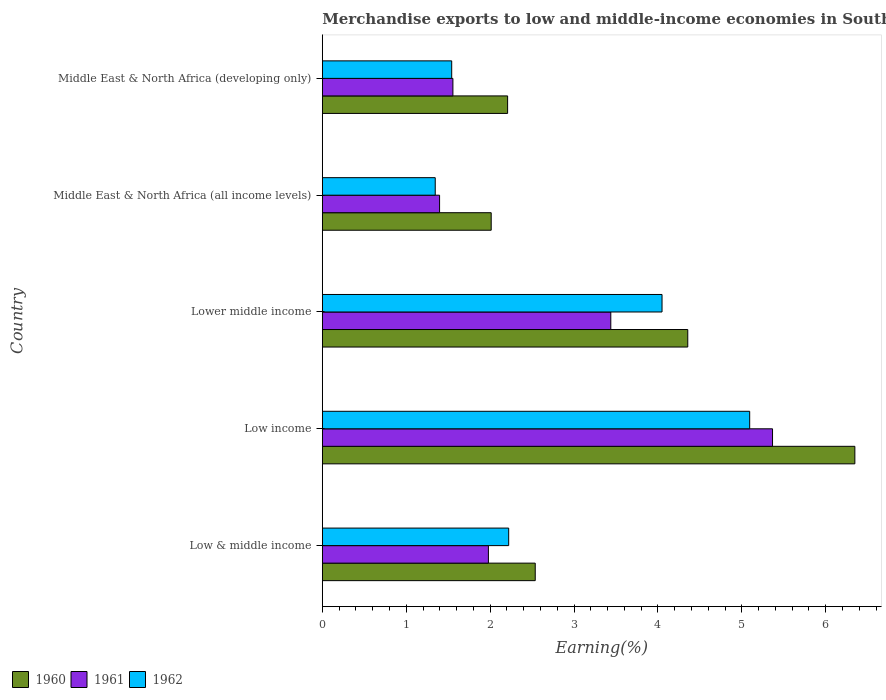How many different coloured bars are there?
Offer a very short reply. 3. How many bars are there on the 2nd tick from the top?
Give a very brief answer. 3. How many bars are there on the 5th tick from the bottom?
Your response must be concise. 3. What is the label of the 2nd group of bars from the top?
Provide a succinct answer. Middle East & North Africa (all income levels). What is the percentage of amount earned from merchandise exports in 1961 in Lower middle income?
Your answer should be compact. 3.44. Across all countries, what is the maximum percentage of amount earned from merchandise exports in 1960?
Offer a very short reply. 6.35. Across all countries, what is the minimum percentage of amount earned from merchandise exports in 1962?
Your answer should be compact. 1.35. In which country was the percentage of amount earned from merchandise exports in 1961 maximum?
Make the answer very short. Low income. In which country was the percentage of amount earned from merchandise exports in 1961 minimum?
Keep it short and to the point. Middle East & North Africa (all income levels). What is the total percentage of amount earned from merchandise exports in 1962 in the graph?
Offer a terse response. 14.25. What is the difference between the percentage of amount earned from merchandise exports in 1960 in Low & middle income and that in Low income?
Offer a very short reply. -3.81. What is the difference between the percentage of amount earned from merchandise exports in 1960 in Lower middle income and the percentage of amount earned from merchandise exports in 1961 in Middle East & North Africa (all income levels)?
Make the answer very short. 2.96. What is the average percentage of amount earned from merchandise exports in 1962 per country?
Make the answer very short. 2.85. What is the difference between the percentage of amount earned from merchandise exports in 1960 and percentage of amount earned from merchandise exports in 1961 in Low income?
Your answer should be compact. 0.98. What is the ratio of the percentage of amount earned from merchandise exports in 1962 in Lower middle income to that in Middle East & North Africa (developing only)?
Make the answer very short. 2.63. Is the percentage of amount earned from merchandise exports in 1962 in Lower middle income less than that in Middle East & North Africa (developing only)?
Ensure brevity in your answer.  No. What is the difference between the highest and the second highest percentage of amount earned from merchandise exports in 1962?
Your answer should be compact. 1.04. What is the difference between the highest and the lowest percentage of amount earned from merchandise exports in 1960?
Your response must be concise. 4.33. In how many countries, is the percentage of amount earned from merchandise exports in 1960 greater than the average percentage of amount earned from merchandise exports in 1960 taken over all countries?
Give a very brief answer. 2. Is it the case that in every country, the sum of the percentage of amount earned from merchandise exports in 1962 and percentage of amount earned from merchandise exports in 1960 is greater than the percentage of amount earned from merchandise exports in 1961?
Keep it short and to the point. Yes. Are all the bars in the graph horizontal?
Give a very brief answer. Yes. How many countries are there in the graph?
Offer a terse response. 5. Are the values on the major ticks of X-axis written in scientific E-notation?
Offer a terse response. No. Where does the legend appear in the graph?
Give a very brief answer. Bottom left. How many legend labels are there?
Your answer should be compact. 3. How are the legend labels stacked?
Give a very brief answer. Horizontal. What is the title of the graph?
Offer a terse response. Merchandise exports to low and middle-income economies in South Asia. What is the label or title of the X-axis?
Offer a very short reply. Earning(%). What is the Earning(%) of 1960 in Low & middle income?
Keep it short and to the point. 2.54. What is the Earning(%) of 1961 in Low & middle income?
Provide a succinct answer. 1.98. What is the Earning(%) in 1962 in Low & middle income?
Provide a short and direct response. 2.22. What is the Earning(%) of 1960 in Low income?
Offer a very short reply. 6.35. What is the Earning(%) in 1961 in Low income?
Keep it short and to the point. 5.37. What is the Earning(%) in 1962 in Low income?
Keep it short and to the point. 5.09. What is the Earning(%) in 1960 in Lower middle income?
Your answer should be very brief. 4.36. What is the Earning(%) of 1961 in Lower middle income?
Provide a short and direct response. 3.44. What is the Earning(%) in 1962 in Lower middle income?
Ensure brevity in your answer.  4.05. What is the Earning(%) in 1960 in Middle East & North Africa (all income levels)?
Keep it short and to the point. 2.01. What is the Earning(%) of 1961 in Middle East & North Africa (all income levels)?
Keep it short and to the point. 1.4. What is the Earning(%) in 1962 in Middle East & North Africa (all income levels)?
Give a very brief answer. 1.35. What is the Earning(%) in 1960 in Middle East & North Africa (developing only)?
Make the answer very short. 2.21. What is the Earning(%) of 1961 in Middle East & North Africa (developing only)?
Your response must be concise. 1.56. What is the Earning(%) of 1962 in Middle East & North Africa (developing only)?
Keep it short and to the point. 1.54. Across all countries, what is the maximum Earning(%) of 1960?
Give a very brief answer. 6.35. Across all countries, what is the maximum Earning(%) in 1961?
Offer a terse response. 5.37. Across all countries, what is the maximum Earning(%) in 1962?
Offer a terse response. 5.09. Across all countries, what is the minimum Earning(%) of 1960?
Offer a very short reply. 2.01. Across all countries, what is the minimum Earning(%) of 1961?
Keep it short and to the point. 1.4. Across all countries, what is the minimum Earning(%) of 1962?
Your response must be concise. 1.35. What is the total Earning(%) in 1960 in the graph?
Make the answer very short. 17.46. What is the total Earning(%) of 1961 in the graph?
Your answer should be very brief. 13.74. What is the total Earning(%) of 1962 in the graph?
Your response must be concise. 14.25. What is the difference between the Earning(%) in 1960 in Low & middle income and that in Low income?
Your response must be concise. -3.81. What is the difference between the Earning(%) in 1961 in Low & middle income and that in Low income?
Keep it short and to the point. -3.39. What is the difference between the Earning(%) in 1962 in Low & middle income and that in Low income?
Make the answer very short. -2.87. What is the difference between the Earning(%) in 1960 in Low & middle income and that in Lower middle income?
Ensure brevity in your answer.  -1.82. What is the difference between the Earning(%) in 1961 in Low & middle income and that in Lower middle income?
Offer a terse response. -1.46. What is the difference between the Earning(%) of 1962 in Low & middle income and that in Lower middle income?
Provide a succinct answer. -1.83. What is the difference between the Earning(%) of 1960 in Low & middle income and that in Middle East & North Africa (all income levels)?
Provide a short and direct response. 0.52. What is the difference between the Earning(%) of 1961 in Low & middle income and that in Middle East & North Africa (all income levels)?
Keep it short and to the point. 0.58. What is the difference between the Earning(%) in 1962 in Low & middle income and that in Middle East & North Africa (all income levels)?
Keep it short and to the point. 0.88. What is the difference between the Earning(%) of 1960 in Low & middle income and that in Middle East & North Africa (developing only)?
Provide a succinct answer. 0.33. What is the difference between the Earning(%) of 1961 in Low & middle income and that in Middle East & North Africa (developing only)?
Offer a terse response. 0.42. What is the difference between the Earning(%) of 1962 in Low & middle income and that in Middle East & North Africa (developing only)?
Your answer should be very brief. 0.68. What is the difference between the Earning(%) in 1960 in Low income and that in Lower middle income?
Offer a terse response. 1.99. What is the difference between the Earning(%) in 1961 in Low income and that in Lower middle income?
Offer a very short reply. 1.93. What is the difference between the Earning(%) of 1962 in Low income and that in Lower middle income?
Your response must be concise. 1.04. What is the difference between the Earning(%) of 1960 in Low income and that in Middle East & North Africa (all income levels)?
Provide a short and direct response. 4.33. What is the difference between the Earning(%) of 1961 in Low income and that in Middle East & North Africa (all income levels)?
Your answer should be very brief. 3.97. What is the difference between the Earning(%) of 1962 in Low income and that in Middle East & North Africa (all income levels)?
Provide a short and direct response. 3.75. What is the difference between the Earning(%) of 1960 in Low income and that in Middle East & North Africa (developing only)?
Provide a succinct answer. 4.14. What is the difference between the Earning(%) of 1961 in Low income and that in Middle East & North Africa (developing only)?
Provide a succinct answer. 3.81. What is the difference between the Earning(%) in 1962 in Low income and that in Middle East & North Africa (developing only)?
Give a very brief answer. 3.55. What is the difference between the Earning(%) of 1960 in Lower middle income and that in Middle East & North Africa (all income levels)?
Your answer should be very brief. 2.34. What is the difference between the Earning(%) of 1961 in Lower middle income and that in Middle East & North Africa (all income levels)?
Your answer should be very brief. 2.04. What is the difference between the Earning(%) in 1962 in Lower middle income and that in Middle East & North Africa (all income levels)?
Provide a short and direct response. 2.7. What is the difference between the Earning(%) in 1960 in Lower middle income and that in Middle East & North Africa (developing only)?
Provide a succinct answer. 2.15. What is the difference between the Earning(%) in 1961 in Lower middle income and that in Middle East & North Africa (developing only)?
Offer a terse response. 1.88. What is the difference between the Earning(%) in 1962 in Lower middle income and that in Middle East & North Africa (developing only)?
Make the answer very short. 2.51. What is the difference between the Earning(%) of 1960 in Middle East & North Africa (all income levels) and that in Middle East & North Africa (developing only)?
Provide a succinct answer. -0.2. What is the difference between the Earning(%) in 1961 in Middle East & North Africa (all income levels) and that in Middle East & North Africa (developing only)?
Offer a very short reply. -0.16. What is the difference between the Earning(%) in 1962 in Middle East & North Africa (all income levels) and that in Middle East & North Africa (developing only)?
Ensure brevity in your answer.  -0.2. What is the difference between the Earning(%) in 1960 in Low & middle income and the Earning(%) in 1961 in Low income?
Keep it short and to the point. -2.83. What is the difference between the Earning(%) in 1960 in Low & middle income and the Earning(%) in 1962 in Low income?
Give a very brief answer. -2.56. What is the difference between the Earning(%) in 1961 in Low & middle income and the Earning(%) in 1962 in Low income?
Give a very brief answer. -3.11. What is the difference between the Earning(%) in 1960 in Low & middle income and the Earning(%) in 1961 in Lower middle income?
Provide a succinct answer. -0.9. What is the difference between the Earning(%) of 1960 in Low & middle income and the Earning(%) of 1962 in Lower middle income?
Give a very brief answer. -1.51. What is the difference between the Earning(%) in 1961 in Low & middle income and the Earning(%) in 1962 in Lower middle income?
Provide a succinct answer. -2.07. What is the difference between the Earning(%) of 1960 in Low & middle income and the Earning(%) of 1961 in Middle East & North Africa (all income levels)?
Make the answer very short. 1.14. What is the difference between the Earning(%) of 1960 in Low & middle income and the Earning(%) of 1962 in Middle East & North Africa (all income levels)?
Give a very brief answer. 1.19. What is the difference between the Earning(%) in 1961 in Low & middle income and the Earning(%) in 1962 in Middle East & North Africa (all income levels)?
Offer a terse response. 0.63. What is the difference between the Earning(%) of 1960 in Low & middle income and the Earning(%) of 1961 in Middle East & North Africa (developing only)?
Ensure brevity in your answer.  0.98. What is the difference between the Earning(%) of 1960 in Low & middle income and the Earning(%) of 1962 in Middle East & North Africa (developing only)?
Keep it short and to the point. 1. What is the difference between the Earning(%) in 1961 in Low & middle income and the Earning(%) in 1962 in Middle East & North Africa (developing only)?
Your answer should be compact. 0.44. What is the difference between the Earning(%) in 1960 in Low income and the Earning(%) in 1961 in Lower middle income?
Ensure brevity in your answer.  2.91. What is the difference between the Earning(%) of 1960 in Low income and the Earning(%) of 1962 in Lower middle income?
Offer a very short reply. 2.3. What is the difference between the Earning(%) in 1961 in Low income and the Earning(%) in 1962 in Lower middle income?
Your response must be concise. 1.32. What is the difference between the Earning(%) in 1960 in Low income and the Earning(%) in 1961 in Middle East & North Africa (all income levels)?
Your answer should be very brief. 4.95. What is the difference between the Earning(%) in 1960 in Low income and the Earning(%) in 1962 in Middle East & North Africa (all income levels)?
Your answer should be compact. 5. What is the difference between the Earning(%) of 1961 in Low income and the Earning(%) of 1962 in Middle East & North Africa (all income levels)?
Offer a terse response. 4.02. What is the difference between the Earning(%) in 1960 in Low income and the Earning(%) in 1961 in Middle East & North Africa (developing only)?
Offer a very short reply. 4.79. What is the difference between the Earning(%) of 1960 in Low income and the Earning(%) of 1962 in Middle East & North Africa (developing only)?
Your response must be concise. 4.81. What is the difference between the Earning(%) of 1961 in Low income and the Earning(%) of 1962 in Middle East & North Africa (developing only)?
Your response must be concise. 3.82. What is the difference between the Earning(%) in 1960 in Lower middle income and the Earning(%) in 1961 in Middle East & North Africa (all income levels)?
Offer a very short reply. 2.96. What is the difference between the Earning(%) of 1960 in Lower middle income and the Earning(%) of 1962 in Middle East & North Africa (all income levels)?
Provide a short and direct response. 3.01. What is the difference between the Earning(%) of 1961 in Lower middle income and the Earning(%) of 1962 in Middle East & North Africa (all income levels)?
Offer a terse response. 2.09. What is the difference between the Earning(%) in 1960 in Lower middle income and the Earning(%) in 1961 in Middle East & North Africa (developing only)?
Provide a short and direct response. 2.8. What is the difference between the Earning(%) in 1960 in Lower middle income and the Earning(%) in 1962 in Middle East & North Africa (developing only)?
Keep it short and to the point. 2.81. What is the difference between the Earning(%) of 1961 in Lower middle income and the Earning(%) of 1962 in Middle East & North Africa (developing only)?
Give a very brief answer. 1.9. What is the difference between the Earning(%) of 1960 in Middle East & North Africa (all income levels) and the Earning(%) of 1961 in Middle East & North Africa (developing only)?
Ensure brevity in your answer.  0.46. What is the difference between the Earning(%) of 1960 in Middle East & North Africa (all income levels) and the Earning(%) of 1962 in Middle East & North Africa (developing only)?
Keep it short and to the point. 0.47. What is the difference between the Earning(%) of 1961 in Middle East & North Africa (all income levels) and the Earning(%) of 1962 in Middle East & North Africa (developing only)?
Your answer should be very brief. -0.14. What is the average Earning(%) in 1960 per country?
Give a very brief answer. 3.49. What is the average Earning(%) of 1961 per country?
Your response must be concise. 2.75. What is the average Earning(%) of 1962 per country?
Provide a succinct answer. 2.85. What is the difference between the Earning(%) in 1960 and Earning(%) in 1961 in Low & middle income?
Provide a short and direct response. 0.56. What is the difference between the Earning(%) in 1960 and Earning(%) in 1962 in Low & middle income?
Offer a terse response. 0.32. What is the difference between the Earning(%) of 1961 and Earning(%) of 1962 in Low & middle income?
Your response must be concise. -0.24. What is the difference between the Earning(%) of 1960 and Earning(%) of 1961 in Low income?
Offer a terse response. 0.98. What is the difference between the Earning(%) of 1960 and Earning(%) of 1962 in Low income?
Keep it short and to the point. 1.25. What is the difference between the Earning(%) in 1961 and Earning(%) in 1962 in Low income?
Your response must be concise. 0.27. What is the difference between the Earning(%) of 1960 and Earning(%) of 1961 in Lower middle income?
Offer a very short reply. 0.92. What is the difference between the Earning(%) of 1960 and Earning(%) of 1962 in Lower middle income?
Offer a very short reply. 0.31. What is the difference between the Earning(%) of 1961 and Earning(%) of 1962 in Lower middle income?
Provide a succinct answer. -0.61. What is the difference between the Earning(%) in 1960 and Earning(%) in 1961 in Middle East & North Africa (all income levels)?
Keep it short and to the point. 0.62. What is the difference between the Earning(%) in 1960 and Earning(%) in 1962 in Middle East & North Africa (all income levels)?
Your response must be concise. 0.67. What is the difference between the Earning(%) of 1961 and Earning(%) of 1962 in Middle East & North Africa (all income levels)?
Offer a very short reply. 0.05. What is the difference between the Earning(%) in 1960 and Earning(%) in 1961 in Middle East & North Africa (developing only)?
Ensure brevity in your answer.  0.65. What is the difference between the Earning(%) in 1960 and Earning(%) in 1962 in Middle East & North Africa (developing only)?
Provide a short and direct response. 0.67. What is the difference between the Earning(%) in 1961 and Earning(%) in 1962 in Middle East & North Africa (developing only)?
Offer a terse response. 0.01. What is the ratio of the Earning(%) of 1960 in Low & middle income to that in Low income?
Offer a terse response. 0.4. What is the ratio of the Earning(%) in 1961 in Low & middle income to that in Low income?
Give a very brief answer. 0.37. What is the ratio of the Earning(%) of 1962 in Low & middle income to that in Low income?
Your answer should be very brief. 0.44. What is the ratio of the Earning(%) of 1960 in Low & middle income to that in Lower middle income?
Ensure brevity in your answer.  0.58. What is the ratio of the Earning(%) in 1961 in Low & middle income to that in Lower middle income?
Ensure brevity in your answer.  0.58. What is the ratio of the Earning(%) in 1962 in Low & middle income to that in Lower middle income?
Offer a terse response. 0.55. What is the ratio of the Earning(%) of 1960 in Low & middle income to that in Middle East & North Africa (all income levels)?
Make the answer very short. 1.26. What is the ratio of the Earning(%) in 1961 in Low & middle income to that in Middle East & North Africa (all income levels)?
Provide a succinct answer. 1.42. What is the ratio of the Earning(%) in 1962 in Low & middle income to that in Middle East & North Africa (all income levels)?
Ensure brevity in your answer.  1.65. What is the ratio of the Earning(%) in 1960 in Low & middle income to that in Middle East & North Africa (developing only)?
Make the answer very short. 1.15. What is the ratio of the Earning(%) in 1961 in Low & middle income to that in Middle East & North Africa (developing only)?
Offer a terse response. 1.27. What is the ratio of the Earning(%) of 1962 in Low & middle income to that in Middle East & North Africa (developing only)?
Make the answer very short. 1.44. What is the ratio of the Earning(%) in 1960 in Low income to that in Lower middle income?
Your answer should be very brief. 1.46. What is the ratio of the Earning(%) in 1961 in Low income to that in Lower middle income?
Offer a very short reply. 1.56. What is the ratio of the Earning(%) of 1962 in Low income to that in Lower middle income?
Offer a very short reply. 1.26. What is the ratio of the Earning(%) of 1960 in Low income to that in Middle East & North Africa (all income levels)?
Your answer should be very brief. 3.15. What is the ratio of the Earning(%) of 1961 in Low income to that in Middle East & North Africa (all income levels)?
Your answer should be very brief. 3.84. What is the ratio of the Earning(%) of 1962 in Low income to that in Middle East & North Africa (all income levels)?
Offer a very short reply. 3.78. What is the ratio of the Earning(%) in 1960 in Low income to that in Middle East & North Africa (developing only)?
Your response must be concise. 2.87. What is the ratio of the Earning(%) in 1961 in Low income to that in Middle East & North Africa (developing only)?
Your response must be concise. 3.45. What is the ratio of the Earning(%) of 1962 in Low income to that in Middle East & North Africa (developing only)?
Ensure brevity in your answer.  3.3. What is the ratio of the Earning(%) in 1960 in Lower middle income to that in Middle East & North Africa (all income levels)?
Keep it short and to the point. 2.16. What is the ratio of the Earning(%) in 1961 in Lower middle income to that in Middle East & North Africa (all income levels)?
Keep it short and to the point. 2.46. What is the ratio of the Earning(%) in 1962 in Lower middle income to that in Middle East & North Africa (all income levels)?
Offer a very short reply. 3.01. What is the ratio of the Earning(%) in 1960 in Lower middle income to that in Middle East & North Africa (developing only)?
Your answer should be compact. 1.97. What is the ratio of the Earning(%) of 1961 in Lower middle income to that in Middle East & North Africa (developing only)?
Your answer should be very brief. 2.21. What is the ratio of the Earning(%) of 1962 in Lower middle income to that in Middle East & North Africa (developing only)?
Give a very brief answer. 2.63. What is the ratio of the Earning(%) in 1960 in Middle East & North Africa (all income levels) to that in Middle East & North Africa (developing only)?
Give a very brief answer. 0.91. What is the ratio of the Earning(%) of 1961 in Middle East & North Africa (all income levels) to that in Middle East & North Africa (developing only)?
Your answer should be very brief. 0.9. What is the ratio of the Earning(%) of 1962 in Middle East & North Africa (all income levels) to that in Middle East & North Africa (developing only)?
Provide a short and direct response. 0.87. What is the difference between the highest and the second highest Earning(%) in 1960?
Your answer should be compact. 1.99. What is the difference between the highest and the second highest Earning(%) in 1961?
Keep it short and to the point. 1.93. What is the difference between the highest and the second highest Earning(%) of 1962?
Offer a terse response. 1.04. What is the difference between the highest and the lowest Earning(%) in 1960?
Ensure brevity in your answer.  4.33. What is the difference between the highest and the lowest Earning(%) of 1961?
Offer a very short reply. 3.97. What is the difference between the highest and the lowest Earning(%) of 1962?
Make the answer very short. 3.75. 